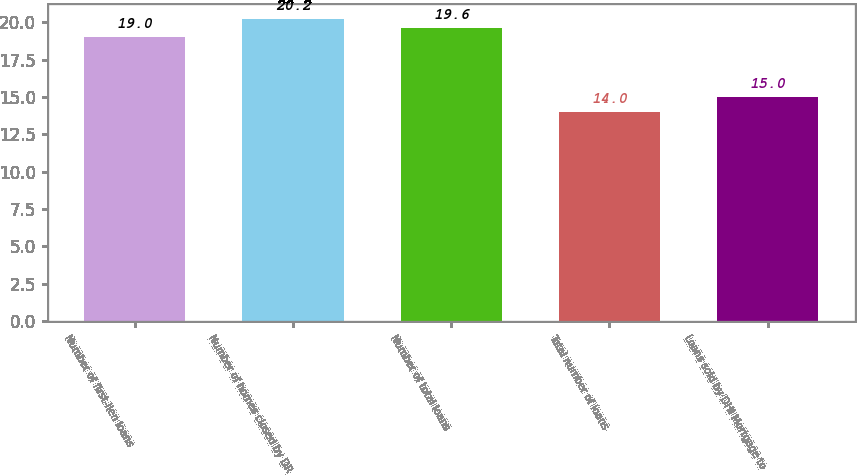Convert chart to OTSL. <chart><loc_0><loc_0><loc_500><loc_500><bar_chart><fcel>Number of first-lien loans<fcel>Number of homes closed by DR<fcel>Number of total loans<fcel>Total number of loans<fcel>Loans sold by DHI Mortgage to<nl><fcel>19<fcel>20.2<fcel>19.6<fcel>14<fcel>15<nl></chart> 